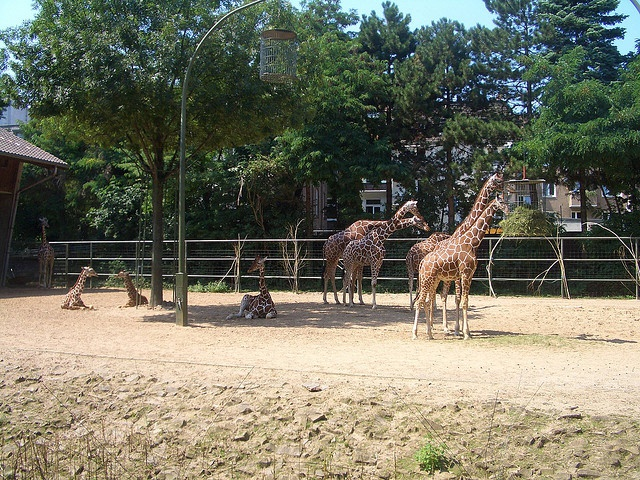Describe the objects in this image and their specific colors. I can see giraffe in lightblue, gray, ivory, tan, and maroon tones, giraffe in lightblue, gray, black, maroon, and darkgray tones, giraffe in lightblue, black, gray, and maroon tones, giraffe in lightblue, brown, black, lightgray, and tan tones, and giraffe in lightblue, black, gray, and darkgray tones in this image. 